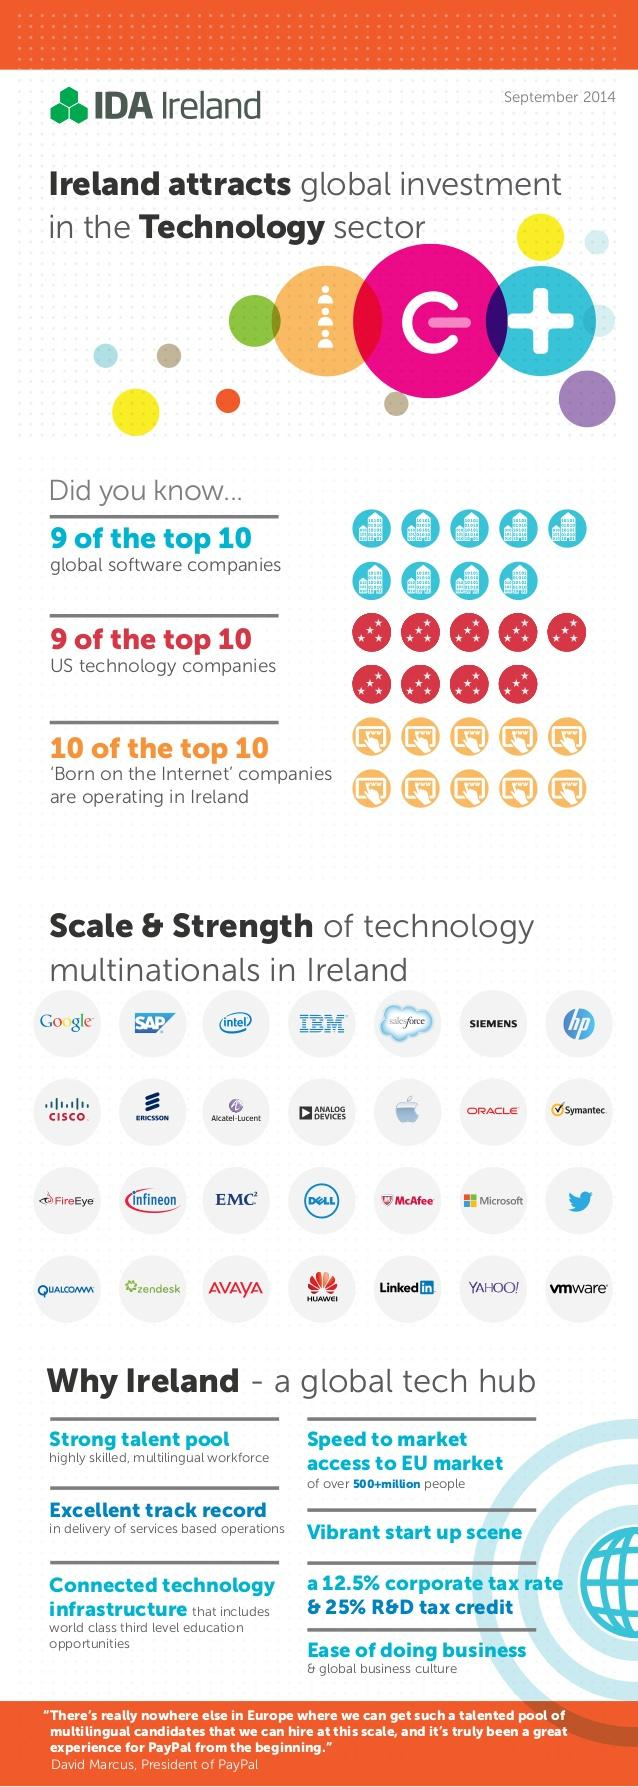Draw attention to some important aspects in this diagram. It is estimated that only one of the 10 global software companies is not operating in Ireland. According to the information provided, only one US technology company out of ten is not operating in Ireland. 